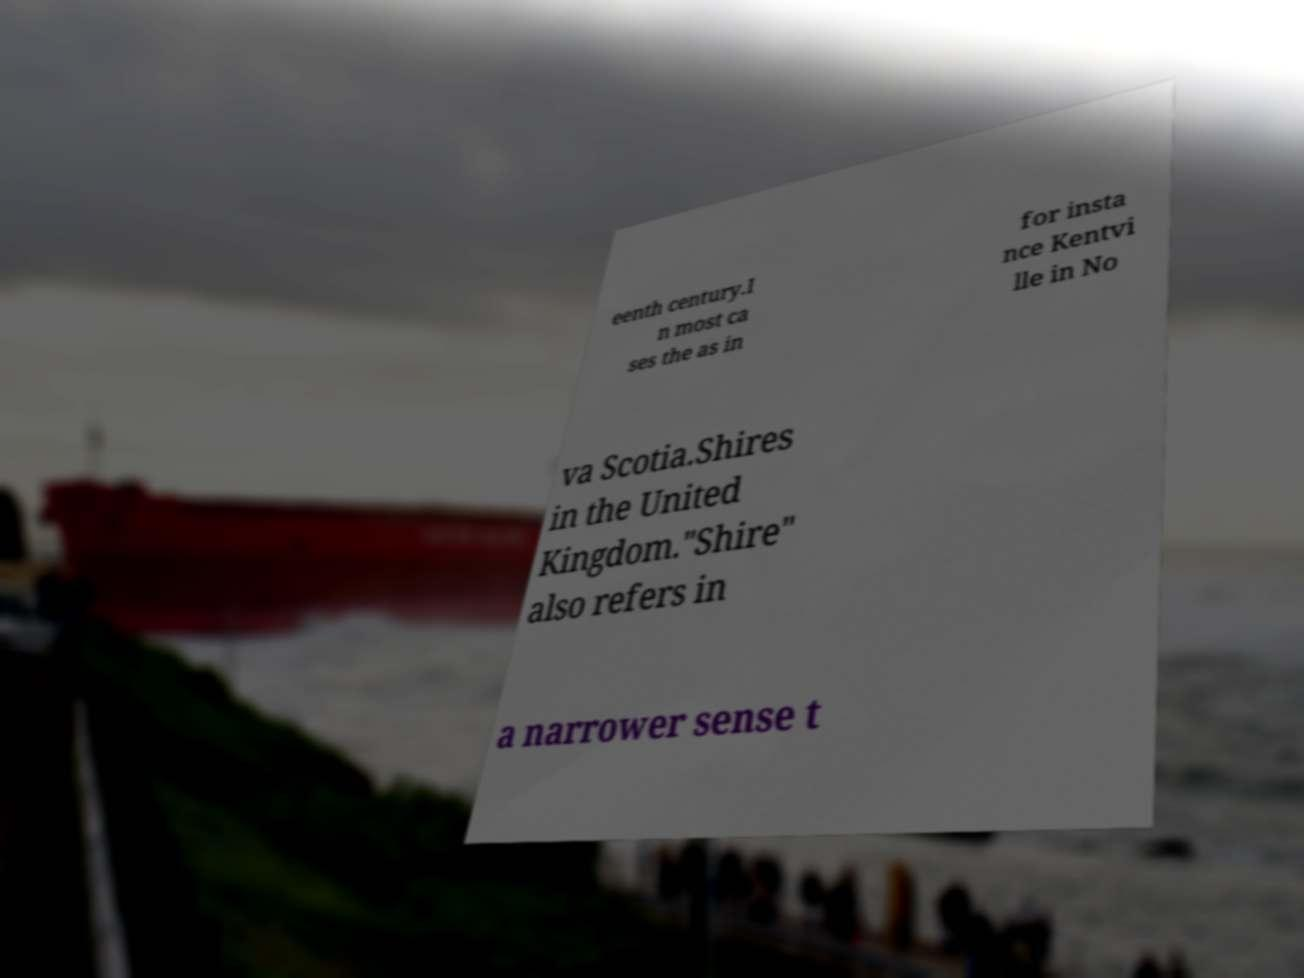There's text embedded in this image that I need extracted. Can you transcribe it verbatim? eenth century.I n most ca ses the as in for insta nce Kentvi lle in No va Scotia.Shires in the United Kingdom."Shire" also refers in a narrower sense t 